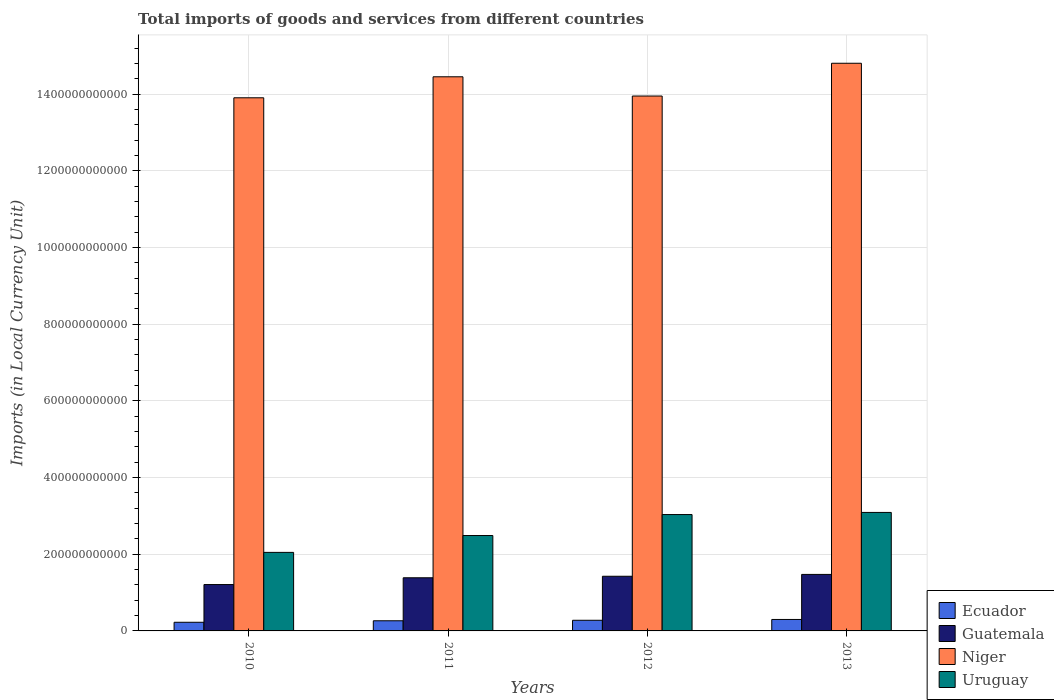How many different coloured bars are there?
Offer a very short reply. 4. How many groups of bars are there?
Give a very brief answer. 4. Are the number of bars per tick equal to the number of legend labels?
Offer a terse response. Yes. Are the number of bars on each tick of the X-axis equal?
Give a very brief answer. Yes. How many bars are there on the 2nd tick from the right?
Keep it short and to the point. 4. What is the label of the 1st group of bars from the left?
Keep it short and to the point. 2010. What is the Amount of goods and services imports in Uruguay in 2010?
Give a very brief answer. 2.05e+11. Across all years, what is the maximum Amount of goods and services imports in Niger?
Keep it short and to the point. 1.48e+12. Across all years, what is the minimum Amount of goods and services imports in Ecuador?
Your answer should be very brief. 2.25e+1. In which year was the Amount of goods and services imports in Guatemala maximum?
Keep it short and to the point. 2013. What is the total Amount of goods and services imports in Niger in the graph?
Your answer should be very brief. 5.71e+12. What is the difference between the Amount of goods and services imports in Niger in 2010 and that in 2011?
Offer a terse response. -5.48e+1. What is the difference between the Amount of goods and services imports in Guatemala in 2011 and the Amount of goods and services imports in Niger in 2013?
Make the answer very short. -1.34e+12. What is the average Amount of goods and services imports in Niger per year?
Your answer should be compact. 1.43e+12. In the year 2011, what is the difference between the Amount of goods and services imports in Niger and Amount of goods and services imports in Ecuador?
Offer a terse response. 1.42e+12. What is the ratio of the Amount of goods and services imports in Guatemala in 2010 to that in 2011?
Your answer should be compact. 0.87. Is the difference between the Amount of goods and services imports in Niger in 2010 and 2013 greater than the difference between the Amount of goods and services imports in Ecuador in 2010 and 2013?
Offer a very short reply. No. What is the difference between the highest and the second highest Amount of goods and services imports in Ecuador?
Offer a very short reply. 2.10e+09. What is the difference between the highest and the lowest Amount of goods and services imports in Guatemala?
Offer a terse response. 2.64e+1. Is the sum of the Amount of goods and services imports in Uruguay in 2011 and 2013 greater than the maximum Amount of goods and services imports in Guatemala across all years?
Your answer should be compact. Yes. Is it the case that in every year, the sum of the Amount of goods and services imports in Uruguay and Amount of goods and services imports in Guatemala is greater than the sum of Amount of goods and services imports in Ecuador and Amount of goods and services imports in Niger?
Offer a terse response. Yes. What does the 2nd bar from the left in 2011 represents?
Offer a terse response. Guatemala. What does the 2nd bar from the right in 2010 represents?
Offer a very short reply. Niger. Is it the case that in every year, the sum of the Amount of goods and services imports in Uruguay and Amount of goods and services imports in Ecuador is greater than the Amount of goods and services imports in Niger?
Your answer should be very brief. No. How many years are there in the graph?
Make the answer very short. 4. What is the difference between two consecutive major ticks on the Y-axis?
Ensure brevity in your answer.  2.00e+11. Does the graph contain any zero values?
Your response must be concise. No. Does the graph contain grids?
Offer a terse response. Yes. How many legend labels are there?
Give a very brief answer. 4. How are the legend labels stacked?
Your response must be concise. Vertical. What is the title of the graph?
Ensure brevity in your answer.  Total imports of goods and services from different countries. What is the label or title of the Y-axis?
Offer a very short reply. Imports (in Local Currency Unit). What is the Imports (in Local Currency Unit) of Ecuador in 2010?
Give a very brief answer. 2.25e+1. What is the Imports (in Local Currency Unit) in Guatemala in 2010?
Your answer should be compact. 1.21e+11. What is the Imports (in Local Currency Unit) of Niger in 2010?
Your answer should be compact. 1.39e+12. What is the Imports (in Local Currency Unit) of Uruguay in 2010?
Your answer should be compact. 2.05e+11. What is the Imports (in Local Currency Unit) of Ecuador in 2011?
Offer a terse response. 2.65e+1. What is the Imports (in Local Currency Unit) in Guatemala in 2011?
Offer a very short reply. 1.39e+11. What is the Imports (in Local Currency Unit) of Niger in 2011?
Your answer should be very brief. 1.45e+12. What is the Imports (in Local Currency Unit) of Uruguay in 2011?
Offer a terse response. 2.49e+11. What is the Imports (in Local Currency Unit) in Ecuador in 2012?
Give a very brief answer. 2.78e+1. What is the Imports (in Local Currency Unit) of Guatemala in 2012?
Your answer should be compact. 1.43e+11. What is the Imports (in Local Currency Unit) in Niger in 2012?
Provide a succinct answer. 1.40e+12. What is the Imports (in Local Currency Unit) in Uruguay in 2012?
Provide a succinct answer. 3.03e+11. What is the Imports (in Local Currency Unit) in Ecuador in 2013?
Provide a succinct answer. 2.99e+1. What is the Imports (in Local Currency Unit) of Guatemala in 2013?
Your answer should be very brief. 1.47e+11. What is the Imports (in Local Currency Unit) of Niger in 2013?
Offer a very short reply. 1.48e+12. What is the Imports (in Local Currency Unit) in Uruguay in 2013?
Make the answer very short. 3.09e+11. Across all years, what is the maximum Imports (in Local Currency Unit) of Ecuador?
Your answer should be very brief. 2.99e+1. Across all years, what is the maximum Imports (in Local Currency Unit) in Guatemala?
Offer a terse response. 1.47e+11. Across all years, what is the maximum Imports (in Local Currency Unit) of Niger?
Provide a short and direct response. 1.48e+12. Across all years, what is the maximum Imports (in Local Currency Unit) in Uruguay?
Ensure brevity in your answer.  3.09e+11. Across all years, what is the minimum Imports (in Local Currency Unit) in Ecuador?
Provide a succinct answer. 2.25e+1. Across all years, what is the minimum Imports (in Local Currency Unit) of Guatemala?
Provide a short and direct response. 1.21e+11. Across all years, what is the minimum Imports (in Local Currency Unit) of Niger?
Offer a terse response. 1.39e+12. Across all years, what is the minimum Imports (in Local Currency Unit) in Uruguay?
Ensure brevity in your answer.  2.05e+11. What is the total Imports (in Local Currency Unit) in Ecuador in the graph?
Give a very brief answer. 1.07e+11. What is the total Imports (in Local Currency Unit) in Guatemala in the graph?
Offer a very short reply. 5.49e+11. What is the total Imports (in Local Currency Unit) of Niger in the graph?
Offer a very short reply. 5.71e+12. What is the total Imports (in Local Currency Unit) in Uruguay in the graph?
Your answer should be compact. 1.07e+12. What is the difference between the Imports (in Local Currency Unit) of Ecuador in 2010 and that in 2011?
Make the answer very short. -3.91e+09. What is the difference between the Imports (in Local Currency Unit) of Guatemala in 2010 and that in 2011?
Offer a terse response. -1.77e+1. What is the difference between the Imports (in Local Currency Unit) of Niger in 2010 and that in 2011?
Your response must be concise. -5.48e+1. What is the difference between the Imports (in Local Currency Unit) in Uruguay in 2010 and that in 2011?
Your answer should be very brief. -4.39e+1. What is the difference between the Imports (in Local Currency Unit) of Ecuador in 2010 and that in 2012?
Keep it short and to the point. -5.23e+09. What is the difference between the Imports (in Local Currency Unit) in Guatemala in 2010 and that in 2012?
Ensure brevity in your answer.  -2.16e+1. What is the difference between the Imports (in Local Currency Unit) in Niger in 2010 and that in 2012?
Your response must be concise. -4.62e+09. What is the difference between the Imports (in Local Currency Unit) of Uruguay in 2010 and that in 2012?
Give a very brief answer. -9.86e+1. What is the difference between the Imports (in Local Currency Unit) in Ecuador in 2010 and that in 2013?
Ensure brevity in your answer.  -7.33e+09. What is the difference between the Imports (in Local Currency Unit) in Guatemala in 2010 and that in 2013?
Offer a terse response. -2.64e+1. What is the difference between the Imports (in Local Currency Unit) in Niger in 2010 and that in 2013?
Make the answer very short. -9.01e+1. What is the difference between the Imports (in Local Currency Unit) of Uruguay in 2010 and that in 2013?
Your answer should be compact. -1.04e+11. What is the difference between the Imports (in Local Currency Unit) in Ecuador in 2011 and that in 2012?
Provide a succinct answer. -1.32e+09. What is the difference between the Imports (in Local Currency Unit) of Guatemala in 2011 and that in 2012?
Make the answer very short. -3.94e+09. What is the difference between the Imports (in Local Currency Unit) of Niger in 2011 and that in 2012?
Offer a very short reply. 5.02e+1. What is the difference between the Imports (in Local Currency Unit) of Uruguay in 2011 and that in 2012?
Give a very brief answer. -5.47e+1. What is the difference between the Imports (in Local Currency Unit) in Ecuador in 2011 and that in 2013?
Provide a succinct answer. -3.42e+09. What is the difference between the Imports (in Local Currency Unit) of Guatemala in 2011 and that in 2013?
Offer a very short reply. -8.75e+09. What is the difference between the Imports (in Local Currency Unit) of Niger in 2011 and that in 2013?
Offer a very short reply. -3.53e+1. What is the difference between the Imports (in Local Currency Unit) of Uruguay in 2011 and that in 2013?
Provide a short and direct response. -6.03e+1. What is the difference between the Imports (in Local Currency Unit) in Ecuador in 2012 and that in 2013?
Offer a terse response. -2.10e+09. What is the difference between the Imports (in Local Currency Unit) in Guatemala in 2012 and that in 2013?
Provide a succinct answer. -4.81e+09. What is the difference between the Imports (in Local Currency Unit) in Niger in 2012 and that in 2013?
Your answer should be very brief. -8.54e+1. What is the difference between the Imports (in Local Currency Unit) of Uruguay in 2012 and that in 2013?
Offer a very short reply. -5.56e+09. What is the difference between the Imports (in Local Currency Unit) of Ecuador in 2010 and the Imports (in Local Currency Unit) of Guatemala in 2011?
Your answer should be very brief. -1.16e+11. What is the difference between the Imports (in Local Currency Unit) of Ecuador in 2010 and the Imports (in Local Currency Unit) of Niger in 2011?
Provide a short and direct response. -1.42e+12. What is the difference between the Imports (in Local Currency Unit) in Ecuador in 2010 and the Imports (in Local Currency Unit) in Uruguay in 2011?
Your answer should be very brief. -2.26e+11. What is the difference between the Imports (in Local Currency Unit) in Guatemala in 2010 and the Imports (in Local Currency Unit) in Niger in 2011?
Your answer should be compact. -1.32e+12. What is the difference between the Imports (in Local Currency Unit) in Guatemala in 2010 and the Imports (in Local Currency Unit) in Uruguay in 2011?
Provide a short and direct response. -1.28e+11. What is the difference between the Imports (in Local Currency Unit) in Niger in 2010 and the Imports (in Local Currency Unit) in Uruguay in 2011?
Provide a succinct answer. 1.14e+12. What is the difference between the Imports (in Local Currency Unit) of Ecuador in 2010 and the Imports (in Local Currency Unit) of Guatemala in 2012?
Offer a terse response. -1.20e+11. What is the difference between the Imports (in Local Currency Unit) of Ecuador in 2010 and the Imports (in Local Currency Unit) of Niger in 2012?
Your response must be concise. -1.37e+12. What is the difference between the Imports (in Local Currency Unit) in Ecuador in 2010 and the Imports (in Local Currency Unit) in Uruguay in 2012?
Make the answer very short. -2.81e+11. What is the difference between the Imports (in Local Currency Unit) of Guatemala in 2010 and the Imports (in Local Currency Unit) of Niger in 2012?
Give a very brief answer. -1.27e+12. What is the difference between the Imports (in Local Currency Unit) of Guatemala in 2010 and the Imports (in Local Currency Unit) of Uruguay in 2012?
Ensure brevity in your answer.  -1.83e+11. What is the difference between the Imports (in Local Currency Unit) of Niger in 2010 and the Imports (in Local Currency Unit) of Uruguay in 2012?
Offer a terse response. 1.09e+12. What is the difference between the Imports (in Local Currency Unit) of Ecuador in 2010 and the Imports (in Local Currency Unit) of Guatemala in 2013?
Your answer should be compact. -1.25e+11. What is the difference between the Imports (in Local Currency Unit) of Ecuador in 2010 and the Imports (in Local Currency Unit) of Niger in 2013?
Provide a short and direct response. -1.46e+12. What is the difference between the Imports (in Local Currency Unit) in Ecuador in 2010 and the Imports (in Local Currency Unit) in Uruguay in 2013?
Your answer should be compact. -2.87e+11. What is the difference between the Imports (in Local Currency Unit) of Guatemala in 2010 and the Imports (in Local Currency Unit) of Niger in 2013?
Ensure brevity in your answer.  -1.36e+12. What is the difference between the Imports (in Local Currency Unit) of Guatemala in 2010 and the Imports (in Local Currency Unit) of Uruguay in 2013?
Make the answer very short. -1.88e+11. What is the difference between the Imports (in Local Currency Unit) in Niger in 2010 and the Imports (in Local Currency Unit) in Uruguay in 2013?
Provide a succinct answer. 1.08e+12. What is the difference between the Imports (in Local Currency Unit) of Ecuador in 2011 and the Imports (in Local Currency Unit) of Guatemala in 2012?
Provide a short and direct response. -1.16e+11. What is the difference between the Imports (in Local Currency Unit) in Ecuador in 2011 and the Imports (in Local Currency Unit) in Niger in 2012?
Your answer should be very brief. -1.37e+12. What is the difference between the Imports (in Local Currency Unit) in Ecuador in 2011 and the Imports (in Local Currency Unit) in Uruguay in 2012?
Provide a succinct answer. -2.77e+11. What is the difference between the Imports (in Local Currency Unit) in Guatemala in 2011 and the Imports (in Local Currency Unit) in Niger in 2012?
Give a very brief answer. -1.26e+12. What is the difference between the Imports (in Local Currency Unit) in Guatemala in 2011 and the Imports (in Local Currency Unit) in Uruguay in 2012?
Offer a very short reply. -1.65e+11. What is the difference between the Imports (in Local Currency Unit) in Niger in 2011 and the Imports (in Local Currency Unit) in Uruguay in 2012?
Keep it short and to the point. 1.14e+12. What is the difference between the Imports (in Local Currency Unit) in Ecuador in 2011 and the Imports (in Local Currency Unit) in Guatemala in 2013?
Keep it short and to the point. -1.21e+11. What is the difference between the Imports (in Local Currency Unit) in Ecuador in 2011 and the Imports (in Local Currency Unit) in Niger in 2013?
Give a very brief answer. -1.45e+12. What is the difference between the Imports (in Local Currency Unit) in Ecuador in 2011 and the Imports (in Local Currency Unit) in Uruguay in 2013?
Provide a succinct answer. -2.83e+11. What is the difference between the Imports (in Local Currency Unit) of Guatemala in 2011 and the Imports (in Local Currency Unit) of Niger in 2013?
Offer a terse response. -1.34e+12. What is the difference between the Imports (in Local Currency Unit) in Guatemala in 2011 and the Imports (in Local Currency Unit) in Uruguay in 2013?
Keep it short and to the point. -1.70e+11. What is the difference between the Imports (in Local Currency Unit) of Niger in 2011 and the Imports (in Local Currency Unit) of Uruguay in 2013?
Make the answer very short. 1.14e+12. What is the difference between the Imports (in Local Currency Unit) of Ecuador in 2012 and the Imports (in Local Currency Unit) of Guatemala in 2013?
Provide a short and direct response. -1.20e+11. What is the difference between the Imports (in Local Currency Unit) in Ecuador in 2012 and the Imports (in Local Currency Unit) in Niger in 2013?
Provide a short and direct response. -1.45e+12. What is the difference between the Imports (in Local Currency Unit) in Ecuador in 2012 and the Imports (in Local Currency Unit) in Uruguay in 2013?
Keep it short and to the point. -2.81e+11. What is the difference between the Imports (in Local Currency Unit) in Guatemala in 2012 and the Imports (in Local Currency Unit) in Niger in 2013?
Give a very brief answer. -1.34e+12. What is the difference between the Imports (in Local Currency Unit) in Guatemala in 2012 and the Imports (in Local Currency Unit) in Uruguay in 2013?
Provide a succinct answer. -1.66e+11. What is the difference between the Imports (in Local Currency Unit) of Niger in 2012 and the Imports (in Local Currency Unit) of Uruguay in 2013?
Your response must be concise. 1.09e+12. What is the average Imports (in Local Currency Unit) in Ecuador per year?
Your response must be concise. 2.67e+1. What is the average Imports (in Local Currency Unit) in Guatemala per year?
Ensure brevity in your answer.  1.37e+11. What is the average Imports (in Local Currency Unit) of Niger per year?
Keep it short and to the point. 1.43e+12. What is the average Imports (in Local Currency Unit) of Uruguay per year?
Make the answer very short. 2.67e+11. In the year 2010, what is the difference between the Imports (in Local Currency Unit) in Ecuador and Imports (in Local Currency Unit) in Guatemala?
Give a very brief answer. -9.84e+1. In the year 2010, what is the difference between the Imports (in Local Currency Unit) of Ecuador and Imports (in Local Currency Unit) of Niger?
Give a very brief answer. -1.37e+12. In the year 2010, what is the difference between the Imports (in Local Currency Unit) of Ecuador and Imports (in Local Currency Unit) of Uruguay?
Provide a short and direct response. -1.82e+11. In the year 2010, what is the difference between the Imports (in Local Currency Unit) in Guatemala and Imports (in Local Currency Unit) in Niger?
Provide a succinct answer. -1.27e+12. In the year 2010, what is the difference between the Imports (in Local Currency Unit) of Guatemala and Imports (in Local Currency Unit) of Uruguay?
Give a very brief answer. -8.39e+1. In the year 2010, what is the difference between the Imports (in Local Currency Unit) of Niger and Imports (in Local Currency Unit) of Uruguay?
Provide a succinct answer. 1.19e+12. In the year 2011, what is the difference between the Imports (in Local Currency Unit) of Ecuador and Imports (in Local Currency Unit) of Guatemala?
Give a very brief answer. -1.12e+11. In the year 2011, what is the difference between the Imports (in Local Currency Unit) in Ecuador and Imports (in Local Currency Unit) in Niger?
Your response must be concise. -1.42e+12. In the year 2011, what is the difference between the Imports (in Local Currency Unit) of Ecuador and Imports (in Local Currency Unit) of Uruguay?
Your answer should be compact. -2.22e+11. In the year 2011, what is the difference between the Imports (in Local Currency Unit) of Guatemala and Imports (in Local Currency Unit) of Niger?
Make the answer very short. -1.31e+12. In the year 2011, what is the difference between the Imports (in Local Currency Unit) in Guatemala and Imports (in Local Currency Unit) in Uruguay?
Ensure brevity in your answer.  -1.10e+11. In the year 2011, what is the difference between the Imports (in Local Currency Unit) in Niger and Imports (in Local Currency Unit) in Uruguay?
Your response must be concise. 1.20e+12. In the year 2012, what is the difference between the Imports (in Local Currency Unit) in Ecuador and Imports (in Local Currency Unit) in Guatemala?
Ensure brevity in your answer.  -1.15e+11. In the year 2012, what is the difference between the Imports (in Local Currency Unit) of Ecuador and Imports (in Local Currency Unit) of Niger?
Provide a short and direct response. -1.37e+12. In the year 2012, what is the difference between the Imports (in Local Currency Unit) in Ecuador and Imports (in Local Currency Unit) in Uruguay?
Give a very brief answer. -2.76e+11. In the year 2012, what is the difference between the Imports (in Local Currency Unit) in Guatemala and Imports (in Local Currency Unit) in Niger?
Offer a terse response. -1.25e+12. In the year 2012, what is the difference between the Imports (in Local Currency Unit) in Guatemala and Imports (in Local Currency Unit) in Uruguay?
Provide a short and direct response. -1.61e+11. In the year 2012, what is the difference between the Imports (in Local Currency Unit) of Niger and Imports (in Local Currency Unit) of Uruguay?
Keep it short and to the point. 1.09e+12. In the year 2013, what is the difference between the Imports (in Local Currency Unit) of Ecuador and Imports (in Local Currency Unit) of Guatemala?
Your answer should be compact. -1.17e+11. In the year 2013, what is the difference between the Imports (in Local Currency Unit) in Ecuador and Imports (in Local Currency Unit) in Niger?
Your answer should be compact. -1.45e+12. In the year 2013, what is the difference between the Imports (in Local Currency Unit) of Ecuador and Imports (in Local Currency Unit) of Uruguay?
Provide a short and direct response. -2.79e+11. In the year 2013, what is the difference between the Imports (in Local Currency Unit) in Guatemala and Imports (in Local Currency Unit) in Niger?
Provide a succinct answer. -1.33e+12. In the year 2013, what is the difference between the Imports (in Local Currency Unit) of Guatemala and Imports (in Local Currency Unit) of Uruguay?
Offer a terse response. -1.62e+11. In the year 2013, what is the difference between the Imports (in Local Currency Unit) in Niger and Imports (in Local Currency Unit) in Uruguay?
Your response must be concise. 1.17e+12. What is the ratio of the Imports (in Local Currency Unit) in Ecuador in 2010 to that in 2011?
Make the answer very short. 0.85. What is the ratio of the Imports (in Local Currency Unit) of Guatemala in 2010 to that in 2011?
Your answer should be compact. 0.87. What is the ratio of the Imports (in Local Currency Unit) in Niger in 2010 to that in 2011?
Provide a short and direct response. 0.96. What is the ratio of the Imports (in Local Currency Unit) in Uruguay in 2010 to that in 2011?
Keep it short and to the point. 0.82. What is the ratio of the Imports (in Local Currency Unit) in Ecuador in 2010 to that in 2012?
Make the answer very short. 0.81. What is the ratio of the Imports (in Local Currency Unit) in Guatemala in 2010 to that in 2012?
Keep it short and to the point. 0.85. What is the ratio of the Imports (in Local Currency Unit) of Niger in 2010 to that in 2012?
Your answer should be compact. 1. What is the ratio of the Imports (in Local Currency Unit) in Uruguay in 2010 to that in 2012?
Your response must be concise. 0.68. What is the ratio of the Imports (in Local Currency Unit) in Ecuador in 2010 to that in 2013?
Make the answer very short. 0.75. What is the ratio of the Imports (in Local Currency Unit) in Guatemala in 2010 to that in 2013?
Give a very brief answer. 0.82. What is the ratio of the Imports (in Local Currency Unit) in Niger in 2010 to that in 2013?
Offer a very short reply. 0.94. What is the ratio of the Imports (in Local Currency Unit) in Uruguay in 2010 to that in 2013?
Ensure brevity in your answer.  0.66. What is the ratio of the Imports (in Local Currency Unit) of Ecuador in 2011 to that in 2012?
Your answer should be very brief. 0.95. What is the ratio of the Imports (in Local Currency Unit) of Guatemala in 2011 to that in 2012?
Give a very brief answer. 0.97. What is the ratio of the Imports (in Local Currency Unit) in Niger in 2011 to that in 2012?
Offer a terse response. 1.04. What is the ratio of the Imports (in Local Currency Unit) in Uruguay in 2011 to that in 2012?
Keep it short and to the point. 0.82. What is the ratio of the Imports (in Local Currency Unit) in Ecuador in 2011 to that in 2013?
Ensure brevity in your answer.  0.89. What is the ratio of the Imports (in Local Currency Unit) of Guatemala in 2011 to that in 2013?
Make the answer very short. 0.94. What is the ratio of the Imports (in Local Currency Unit) of Niger in 2011 to that in 2013?
Your answer should be very brief. 0.98. What is the ratio of the Imports (in Local Currency Unit) of Uruguay in 2011 to that in 2013?
Offer a terse response. 0.81. What is the ratio of the Imports (in Local Currency Unit) of Ecuador in 2012 to that in 2013?
Make the answer very short. 0.93. What is the ratio of the Imports (in Local Currency Unit) of Guatemala in 2012 to that in 2013?
Your answer should be very brief. 0.97. What is the ratio of the Imports (in Local Currency Unit) in Niger in 2012 to that in 2013?
Make the answer very short. 0.94. What is the difference between the highest and the second highest Imports (in Local Currency Unit) of Ecuador?
Make the answer very short. 2.10e+09. What is the difference between the highest and the second highest Imports (in Local Currency Unit) of Guatemala?
Keep it short and to the point. 4.81e+09. What is the difference between the highest and the second highest Imports (in Local Currency Unit) of Niger?
Make the answer very short. 3.53e+1. What is the difference between the highest and the second highest Imports (in Local Currency Unit) of Uruguay?
Give a very brief answer. 5.56e+09. What is the difference between the highest and the lowest Imports (in Local Currency Unit) in Ecuador?
Provide a short and direct response. 7.33e+09. What is the difference between the highest and the lowest Imports (in Local Currency Unit) in Guatemala?
Offer a very short reply. 2.64e+1. What is the difference between the highest and the lowest Imports (in Local Currency Unit) in Niger?
Provide a short and direct response. 9.01e+1. What is the difference between the highest and the lowest Imports (in Local Currency Unit) in Uruguay?
Your response must be concise. 1.04e+11. 